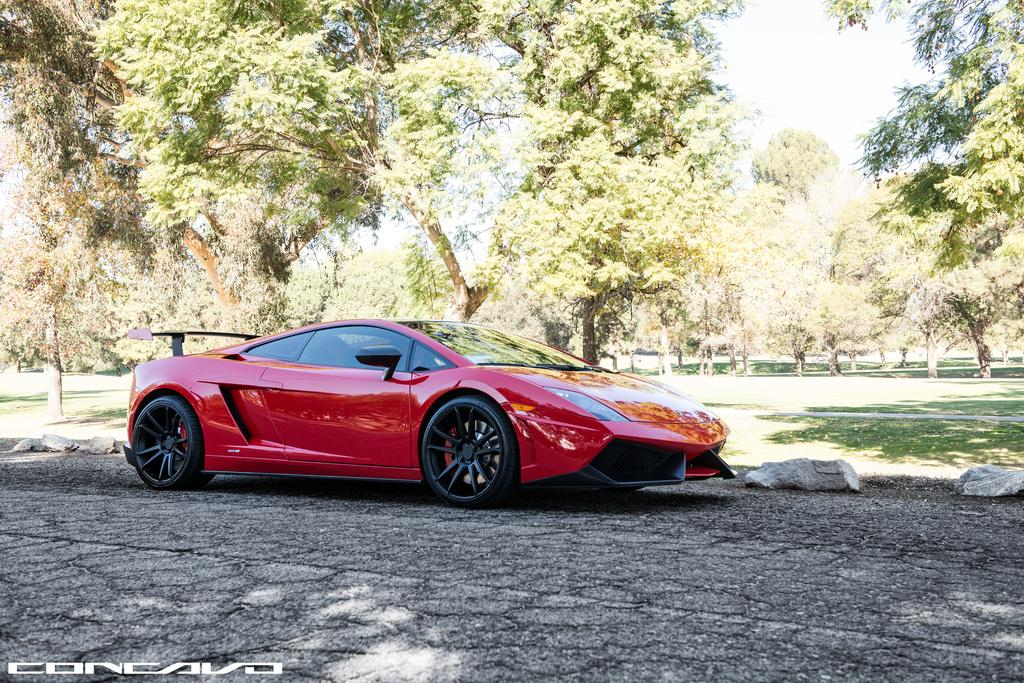What is the main subject of the image? There is a car on the road in the image. What can be seen in the background of the image? There is grass and trees in the background of the image. Is there any text present in the image? Yes, there is some text in the bottom left corner of the image. What type of heart is visible in the image? There is no heart present in the image. Is there an army marching in the background of the image? There is no army or any indication of military presence in the image. 